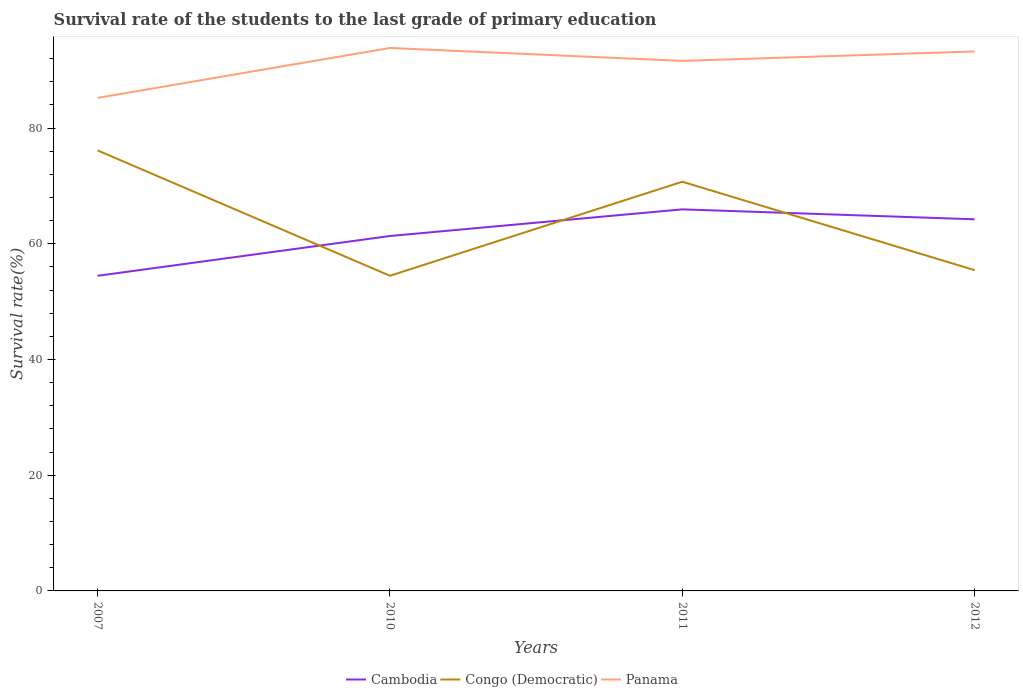How many different coloured lines are there?
Keep it short and to the point. 3. Does the line corresponding to Panama intersect with the line corresponding to Congo (Democratic)?
Your answer should be very brief. No. Across all years, what is the maximum survival rate of the students in Cambodia?
Your answer should be very brief. 54.46. What is the total survival rate of the students in Panama in the graph?
Your answer should be very brief. -6.4. What is the difference between the highest and the second highest survival rate of the students in Cambodia?
Your answer should be compact. 11.49. What is the difference between the highest and the lowest survival rate of the students in Panama?
Give a very brief answer. 3. How many lines are there?
Your answer should be very brief. 3. How many years are there in the graph?
Offer a terse response. 4. What is the difference between two consecutive major ticks on the Y-axis?
Provide a short and direct response. 20. Are the values on the major ticks of Y-axis written in scientific E-notation?
Offer a very short reply. No. Does the graph contain grids?
Provide a short and direct response. No. Where does the legend appear in the graph?
Provide a short and direct response. Bottom center. How are the legend labels stacked?
Provide a succinct answer. Horizontal. What is the title of the graph?
Ensure brevity in your answer.  Survival rate of the students to the last grade of primary education. What is the label or title of the X-axis?
Give a very brief answer. Years. What is the label or title of the Y-axis?
Provide a succinct answer. Survival rate(%). What is the Survival rate(%) in Cambodia in 2007?
Offer a very short reply. 54.46. What is the Survival rate(%) in Congo (Democratic) in 2007?
Provide a short and direct response. 76.14. What is the Survival rate(%) of Panama in 2007?
Keep it short and to the point. 85.21. What is the Survival rate(%) in Cambodia in 2010?
Give a very brief answer. 61.34. What is the Survival rate(%) in Congo (Democratic) in 2010?
Offer a terse response. 54.47. What is the Survival rate(%) of Panama in 2010?
Provide a succinct answer. 93.84. What is the Survival rate(%) in Cambodia in 2011?
Offer a terse response. 65.95. What is the Survival rate(%) in Congo (Democratic) in 2011?
Your response must be concise. 70.73. What is the Survival rate(%) of Panama in 2011?
Keep it short and to the point. 91.61. What is the Survival rate(%) in Cambodia in 2012?
Provide a short and direct response. 64.23. What is the Survival rate(%) of Congo (Democratic) in 2012?
Keep it short and to the point. 55.44. What is the Survival rate(%) of Panama in 2012?
Your answer should be very brief. 93.24. Across all years, what is the maximum Survival rate(%) in Cambodia?
Provide a short and direct response. 65.95. Across all years, what is the maximum Survival rate(%) of Congo (Democratic)?
Offer a terse response. 76.14. Across all years, what is the maximum Survival rate(%) of Panama?
Provide a succinct answer. 93.84. Across all years, what is the minimum Survival rate(%) of Cambodia?
Offer a terse response. 54.46. Across all years, what is the minimum Survival rate(%) in Congo (Democratic)?
Offer a terse response. 54.47. Across all years, what is the minimum Survival rate(%) in Panama?
Your response must be concise. 85.21. What is the total Survival rate(%) of Cambodia in the graph?
Give a very brief answer. 245.98. What is the total Survival rate(%) in Congo (Democratic) in the graph?
Your response must be concise. 256.78. What is the total Survival rate(%) in Panama in the graph?
Your response must be concise. 363.91. What is the difference between the Survival rate(%) of Cambodia in 2007 and that in 2010?
Your response must be concise. -6.88. What is the difference between the Survival rate(%) of Congo (Democratic) in 2007 and that in 2010?
Your response must be concise. 21.67. What is the difference between the Survival rate(%) of Panama in 2007 and that in 2010?
Your answer should be very brief. -8.63. What is the difference between the Survival rate(%) of Cambodia in 2007 and that in 2011?
Keep it short and to the point. -11.49. What is the difference between the Survival rate(%) in Congo (Democratic) in 2007 and that in 2011?
Your answer should be compact. 5.41. What is the difference between the Survival rate(%) in Panama in 2007 and that in 2011?
Your answer should be very brief. -6.4. What is the difference between the Survival rate(%) in Cambodia in 2007 and that in 2012?
Your answer should be very brief. -9.77. What is the difference between the Survival rate(%) of Congo (Democratic) in 2007 and that in 2012?
Ensure brevity in your answer.  20.7. What is the difference between the Survival rate(%) of Panama in 2007 and that in 2012?
Give a very brief answer. -8.03. What is the difference between the Survival rate(%) of Cambodia in 2010 and that in 2011?
Offer a very short reply. -4.61. What is the difference between the Survival rate(%) in Congo (Democratic) in 2010 and that in 2011?
Provide a succinct answer. -16.26. What is the difference between the Survival rate(%) in Panama in 2010 and that in 2011?
Keep it short and to the point. 2.23. What is the difference between the Survival rate(%) in Cambodia in 2010 and that in 2012?
Your response must be concise. -2.89. What is the difference between the Survival rate(%) in Congo (Democratic) in 2010 and that in 2012?
Offer a terse response. -0.97. What is the difference between the Survival rate(%) of Panama in 2010 and that in 2012?
Provide a succinct answer. 0.6. What is the difference between the Survival rate(%) in Cambodia in 2011 and that in 2012?
Make the answer very short. 1.72. What is the difference between the Survival rate(%) in Congo (Democratic) in 2011 and that in 2012?
Ensure brevity in your answer.  15.28. What is the difference between the Survival rate(%) in Panama in 2011 and that in 2012?
Offer a very short reply. -1.63. What is the difference between the Survival rate(%) of Cambodia in 2007 and the Survival rate(%) of Congo (Democratic) in 2010?
Provide a succinct answer. -0.01. What is the difference between the Survival rate(%) of Cambodia in 2007 and the Survival rate(%) of Panama in 2010?
Keep it short and to the point. -39.38. What is the difference between the Survival rate(%) in Congo (Democratic) in 2007 and the Survival rate(%) in Panama in 2010?
Offer a terse response. -17.7. What is the difference between the Survival rate(%) in Cambodia in 2007 and the Survival rate(%) in Congo (Democratic) in 2011?
Your response must be concise. -16.26. What is the difference between the Survival rate(%) in Cambodia in 2007 and the Survival rate(%) in Panama in 2011?
Provide a short and direct response. -37.15. What is the difference between the Survival rate(%) of Congo (Democratic) in 2007 and the Survival rate(%) of Panama in 2011?
Offer a terse response. -15.47. What is the difference between the Survival rate(%) of Cambodia in 2007 and the Survival rate(%) of Congo (Democratic) in 2012?
Offer a terse response. -0.98. What is the difference between the Survival rate(%) of Cambodia in 2007 and the Survival rate(%) of Panama in 2012?
Your answer should be very brief. -38.78. What is the difference between the Survival rate(%) of Congo (Democratic) in 2007 and the Survival rate(%) of Panama in 2012?
Give a very brief answer. -17.1. What is the difference between the Survival rate(%) in Cambodia in 2010 and the Survival rate(%) in Congo (Democratic) in 2011?
Keep it short and to the point. -9.38. What is the difference between the Survival rate(%) of Cambodia in 2010 and the Survival rate(%) of Panama in 2011?
Provide a succinct answer. -30.27. What is the difference between the Survival rate(%) in Congo (Democratic) in 2010 and the Survival rate(%) in Panama in 2011?
Offer a very short reply. -37.14. What is the difference between the Survival rate(%) in Cambodia in 2010 and the Survival rate(%) in Congo (Democratic) in 2012?
Provide a short and direct response. 5.9. What is the difference between the Survival rate(%) in Cambodia in 2010 and the Survival rate(%) in Panama in 2012?
Keep it short and to the point. -31.9. What is the difference between the Survival rate(%) of Congo (Democratic) in 2010 and the Survival rate(%) of Panama in 2012?
Your answer should be compact. -38.77. What is the difference between the Survival rate(%) of Cambodia in 2011 and the Survival rate(%) of Congo (Democratic) in 2012?
Ensure brevity in your answer.  10.51. What is the difference between the Survival rate(%) of Cambodia in 2011 and the Survival rate(%) of Panama in 2012?
Your response must be concise. -27.29. What is the difference between the Survival rate(%) in Congo (Democratic) in 2011 and the Survival rate(%) in Panama in 2012?
Your answer should be compact. -22.51. What is the average Survival rate(%) in Cambodia per year?
Ensure brevity in your answer.  61.5. What is the average Survival rate(%) of Congo (Democratic) per year?
Your answer should be very brief. 64.19. What is the average Survival rate(%) of Panama per year?
Your response must be concise. 90.98. In the year 2007, what is the difference between the Survival rate(%) of Cambodia and Survival rate(%) of Congo (Democratic)?
Make the answer very short. -21.68. In the year 2007, what is the difference between the Survival rate(%) of Cambodia and Survival rate(%) of Panama?
Provide a short and direct response. -30.75. In the year 2007, what is the difference between the Survival rate(%) in Congo (Democratic) and Survival rate(%) in Panama?
Your response must be concise. -9.08. In the year 2010, what is the difference between the Survival rate(%) of Cambodia and Survival rate(%) of Congo (Democratic)?
Offer a very short reply. 6.87. In the year 2010, what is the difference between the Survival rate(%) of Cambodia and Survival rate(%) of Panama?
Your answer should be compact. -32.5. In the year 2010, what is the difference between the Survival rate(%) in Congo (Democratic) and Survival rate(%) in Panama?
Offer a terse response. -39.37. In the year 2011, what is the difference between the Survival rate(%) in Cambodia and Survival rate(%) in Congo (Democratic)?
Give a very brief answer. -4.78. In the year 2011, what is the difference between the Survival rate(%) of Cambodia and Survival rate(%) of Panama?
Your answer should be compact. -25.66. In the year 2011, what is the difference between the Survival rate(%) in Congo (Democratic) and Survival rate(%) in Panama?
Offer a very short reply. -20.88. In the year 2012, what is the difference between the Survival rate(%) of Cambodia and Survival rate(%) of Congo (Democratic)?
Give a very brief answer. 8.79. In the year 2012, what is the difference between the Survival rate(%) in Cambodia and Survival rate(%) in Panama?
Give a very brief answer. -29.01. In the year 2012, what is the difference between the Survival rate(%) of Congo (Democratic) and Survival rate(%) of Panama?
Provide a short and direct response. -37.8. What is the ratio of the Survival rate(%) in Cambodia in 2007 to that in 2010?
Ensure brevity in your answer.  0.89. What is the ratio of the Survival rate(%) in Congo (Democratic) in 2007 to that in 2010?
Provide a short and direct response. 1.4. What is the ratio of the Survival rate(%) of Panama in 2007 to that in 2010?
Offer a very short reply. 0.91. What is the ratio of the Survival rate(%) in Cambodia in 2007 to that in 2011?
Offer a terse response. 0.83. What is the ratio of the Survival rate(%) in Congo (Democratic) in 2007 to that in 2011?
Offer a very short reply. 1.08. What is the ratio of the Survival rate(%) in Panama in 2007 to that in 2011?
Give a very brief answer. 0.93. What is the ratio of the Survival rate(%) of Cambodia in 2007 to that in 2012?
Your answer should be very brief. 0.85. What is the ratio of the Survival rate(%) in Congo (Democratic) in 2007 to that in 2012?
Provide a short and direct response. 1.37. What is the ratio of the Survival rate(%) of Panama in 2007 to that in 2012?
Provide a succinct answer. 0.91. What is the ratio of the Survival rate(%) in Cambodia in 2010 to that in 2011?
Your answer should be very brief. 0.93. What is the ratio of the Survival rate(%) in Congo (Democratic) in 2010 to that in 2011?
Ensure brevity in your answer.  0.77. What is the ratio of the Survival rate(%) in Panama in 2010 to that in 2011?
Keep it short and to the point. 1.02. What is the ratio of the Survival rate(%) of Cambodia in 2010 to that in 2012?
Offer a terse response. 0.96. What is the ratio of the Survival rate(%) of Congo (Democratic) in 2010 to that in 2012?
Ensure brevity in your answer.  0.98. What is the ratio of the Survival rate(%) in Cambodia in 2011 to that in 2012?
Ensure brevity in your answer.  1.03. What is the ratio of the Survival rate(%) in Congo (Democratic) in 2011 to that in 2012?
Ensure brevity in your answer.  1.28. What is the ratio of the Survival rate(%) in Panama in 2011 to that in 2012?
Provide a succinct answer. 0.98. What is the difference between the highest and the second highest Survival rate(%) of Cambodia?
Offer a very short reply. 1.72. What is the difference between the highest and the second highest Survival rate(%) of Congo (Democratic)?
Offer a terse response. 5.41. What is the difference between the highest and the second highest Survival rate(%) of Panama?
Provide a succinct answer. 0.6. What is the difference between the highest and the lowest Survival rate(%) of Cambodia?
Your answer should be very brief. 11.49. What is the difference between the highest and the lowest Survival rate(%) of Congo (Democratic)?
Make the answer very short. 21.67. What is the difference between the highest and the lowest Survival rate(%) of Panama?
Your answer should be very brief. 8.63. 